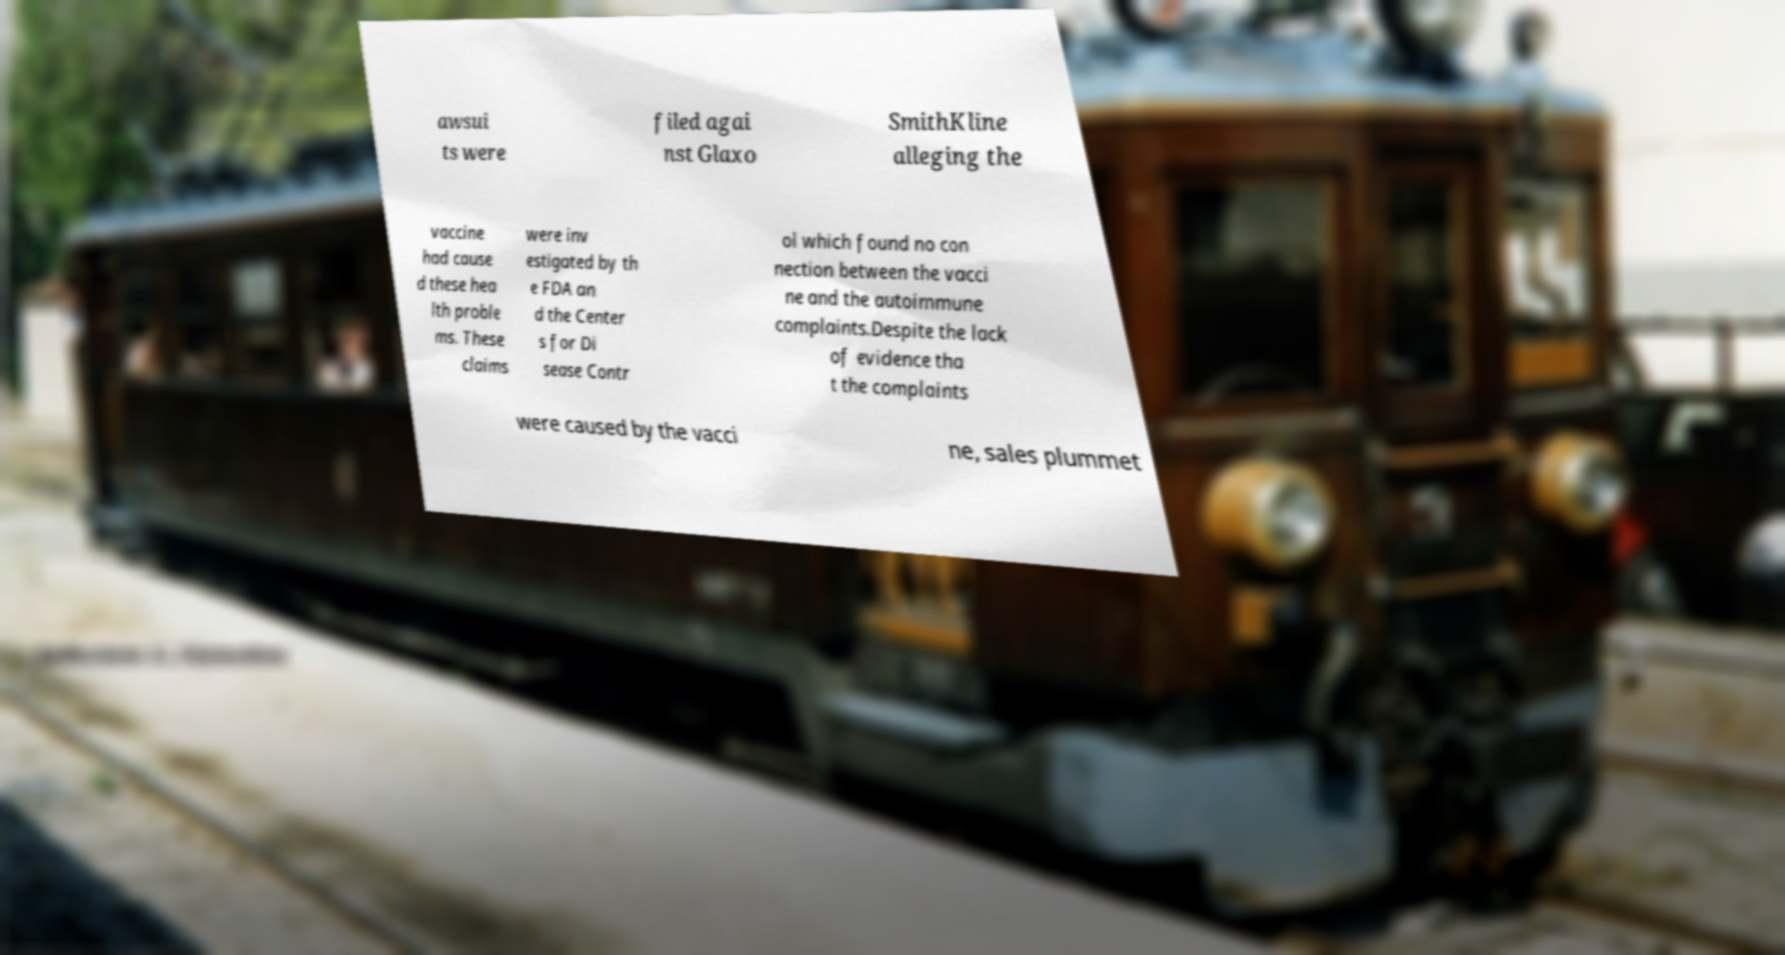I need the written content from this picture converted into text. Can you do that? awsui ts were filed agai nst Glaxo SmithKline alleging the vaccine had cause d these hea lth proble ms. These claims were inv estigated by th e FDA an d the Center s for Di sease Contr ol which found no con nection between the vacci ne and the autoimmune complaints.Despite the lack of evidence tha t the complaints were caused by the vacci ne, sales plummet 